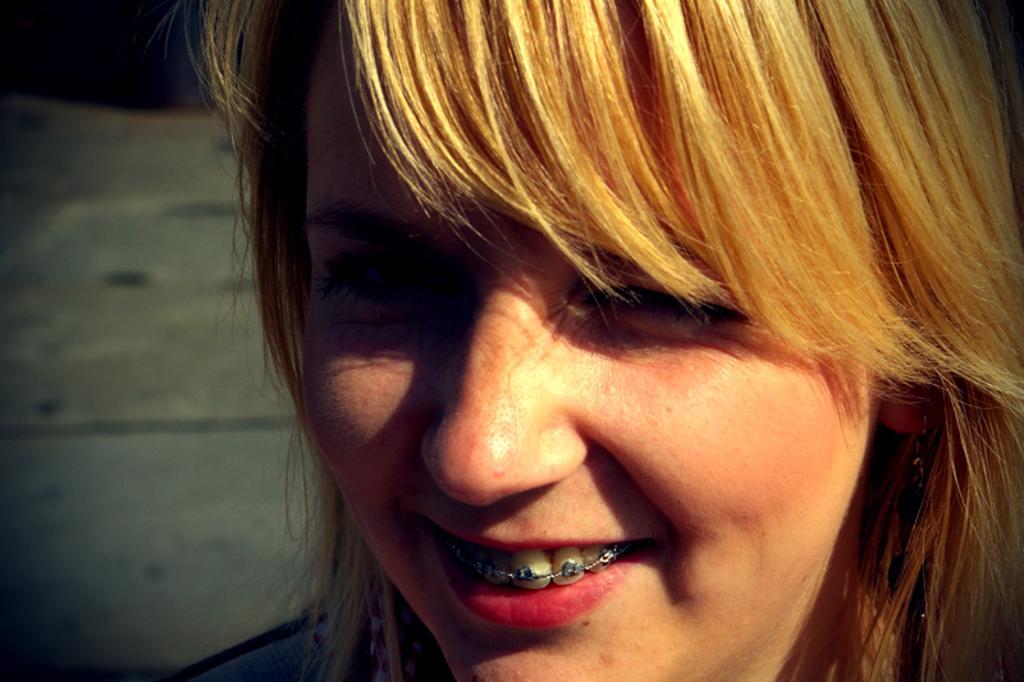Describe this image in one or two sentences. In this picture we can see a woman with brown hair. We can see braces on her teeth and she is smiling. 